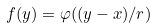<formula> <loc_0><loc_0><loc_500><loc_500>f ( y ) = \varphi ( ( y - x ) / r )</formula> 